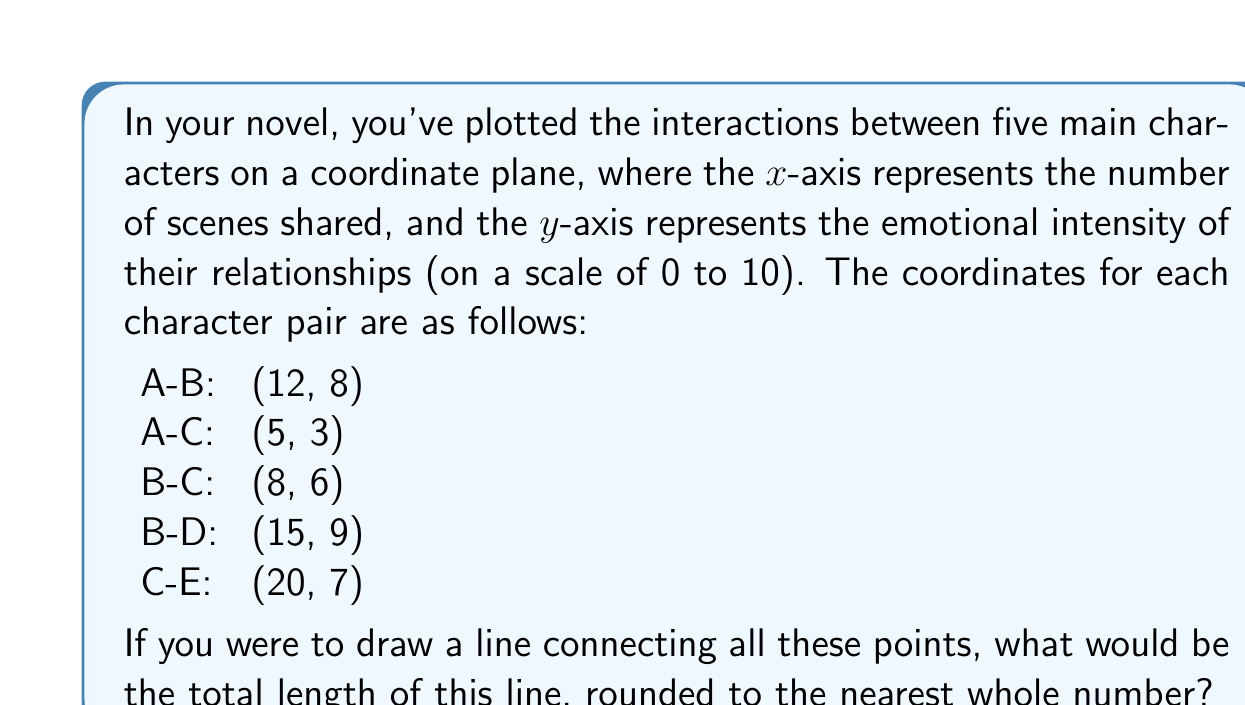Can you answer this question? To solve this problem, we need to calculate the distance between each pair of points and then sum these distances. We'll use the distance formula between two points $(x_1, y_1)$ and $(x_2, y_2)$:

$$ d = \sqrt{(x_2 - x_1)^2 + (y_2 - y_1)^2} $$

Let's calculate each distance:

1. A-B to A-C:
   $d_1 = \sqrt{(5 - 12)^2 + (3 - 8)^2} = \sqrt{49 + 25} = \sqrt{74} \approx 8.60$

2. A-C to B-C:
   $d_2 = \sqrt{(8 - 5)^2 + (6 - 3)^2} = \sqrt{9 + 9} = \sqrt{18} \approx 4.24$

3. B-C to B-D:
   $d_3 = \sqrt{(15 - 8)^2 + (9 - 6)^2} = \sqrt{49 + 9} = \sqrt{58} \approx 7.62$

4. B-D to C-E:
   $d_4 = \sqrt{(20 - 15)^2 + (7 - 9)^2} = \sqrt{25 + 4} = \sqrt{29} \approx 5.39$

Now, we sum all these distances:

$$ \text{Total Length} = d_1 + d_2 + d_3 + d_4 $$
$$ \text{Total Length} \approx 8.60 + 4.24 + 7.62 + 5.39 = 25.85 $$

Rounding to the nearest whole number, we get 26.
Answer: 26 